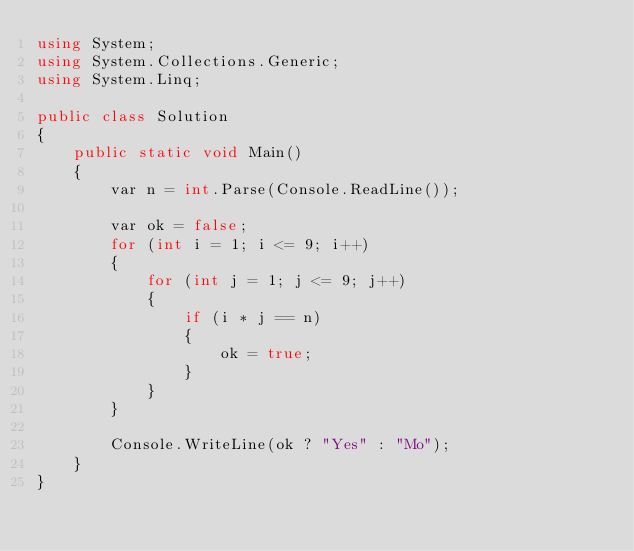Convert code to text. <code><loc_0><loc_0><loc_500><loc_500><_C#_>using System;
using System.Collections.Generic;
using System.Linq;

public class Solution
{
    public static void Main()
    {
        var n = int.Parse(Console.ReadLine());

        var ok = false;
        for (int i = 1; i <= 9; i++)
        {
            for (int j = 1; j <= 9; j++)
            {
                if (i * j == n)
                {
                    ok = true;
                }
            }
        }

        Console.WriteLine(ok ? "Yes" : "Mo");
    }
}</code> 